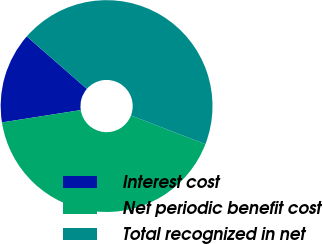Convert chart to OTSL. <chart><loc_0><loc_0><loc_500><loc_500><pie_chart><fcel>Interest cost<fcel>Net periodic benefit cost<fcel>Total recognized in net<nl><fcel>13.89%<fcel>41.67%<fcel>44.44%<nl></chart> 